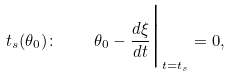<formula> <loc_0><loc_0><loc_500><loc_500>t _ { s } ( \theta _ { 0 } ) \colon \quad \theta _ { 0 } - \frac { d \xi } { d t } \Big | _ { t = t _ { s } } = 0 ,</formula> 